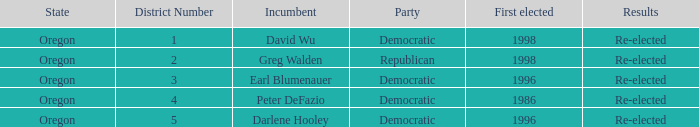What was the result of the Oregon 5 District incumbent who was first elected in 1996? Re-elected. 